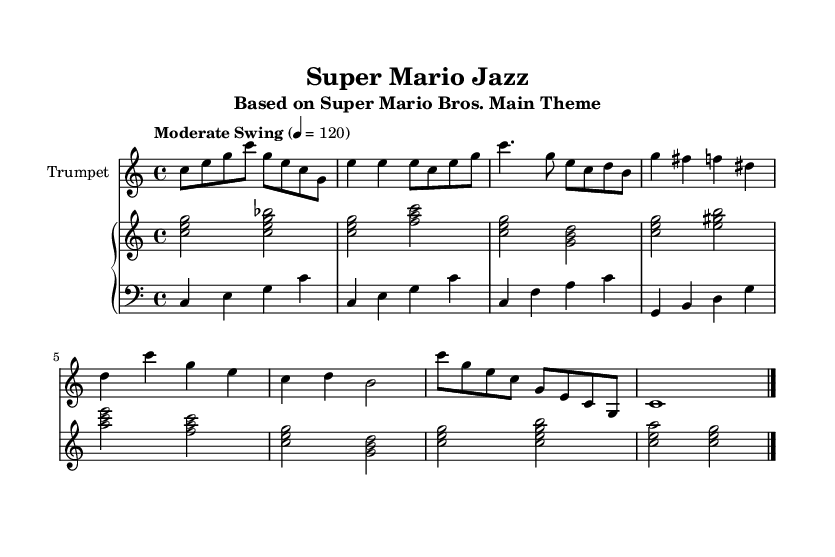What is the key signature of this music? The key signature is C major, which has no sharps or flats.
Answer: C major What is the time signature of this piece? The time signature is indicated as 4/4, meaning there are four beats in each measure.
Answer: 4/4 What tempo marking is used in the music? The tempo marking is "Moderate Swing" with a metronome indication of 120 beats per minute.
Answer: Moderate Swing 4 = 120 How many measures are in the full piece? Counting each section (Intro, Theme A, Theme B, Outro), there are 12 measures in total.
Answer: 12 What is the first note played by the trumpet? The first note in the trumpet part is C, which is the start of the Intro section.
Answer: C Which instrument starts with a walking bass line? The bass line in the specified music is played by the piano's left hand, designated as 'pianoLH.'
Answer: Piano How many chords are played in Theme A by the piano? Theme A has three distinct chords played, as observed in the chords outlined for that section.
Answer: 3 